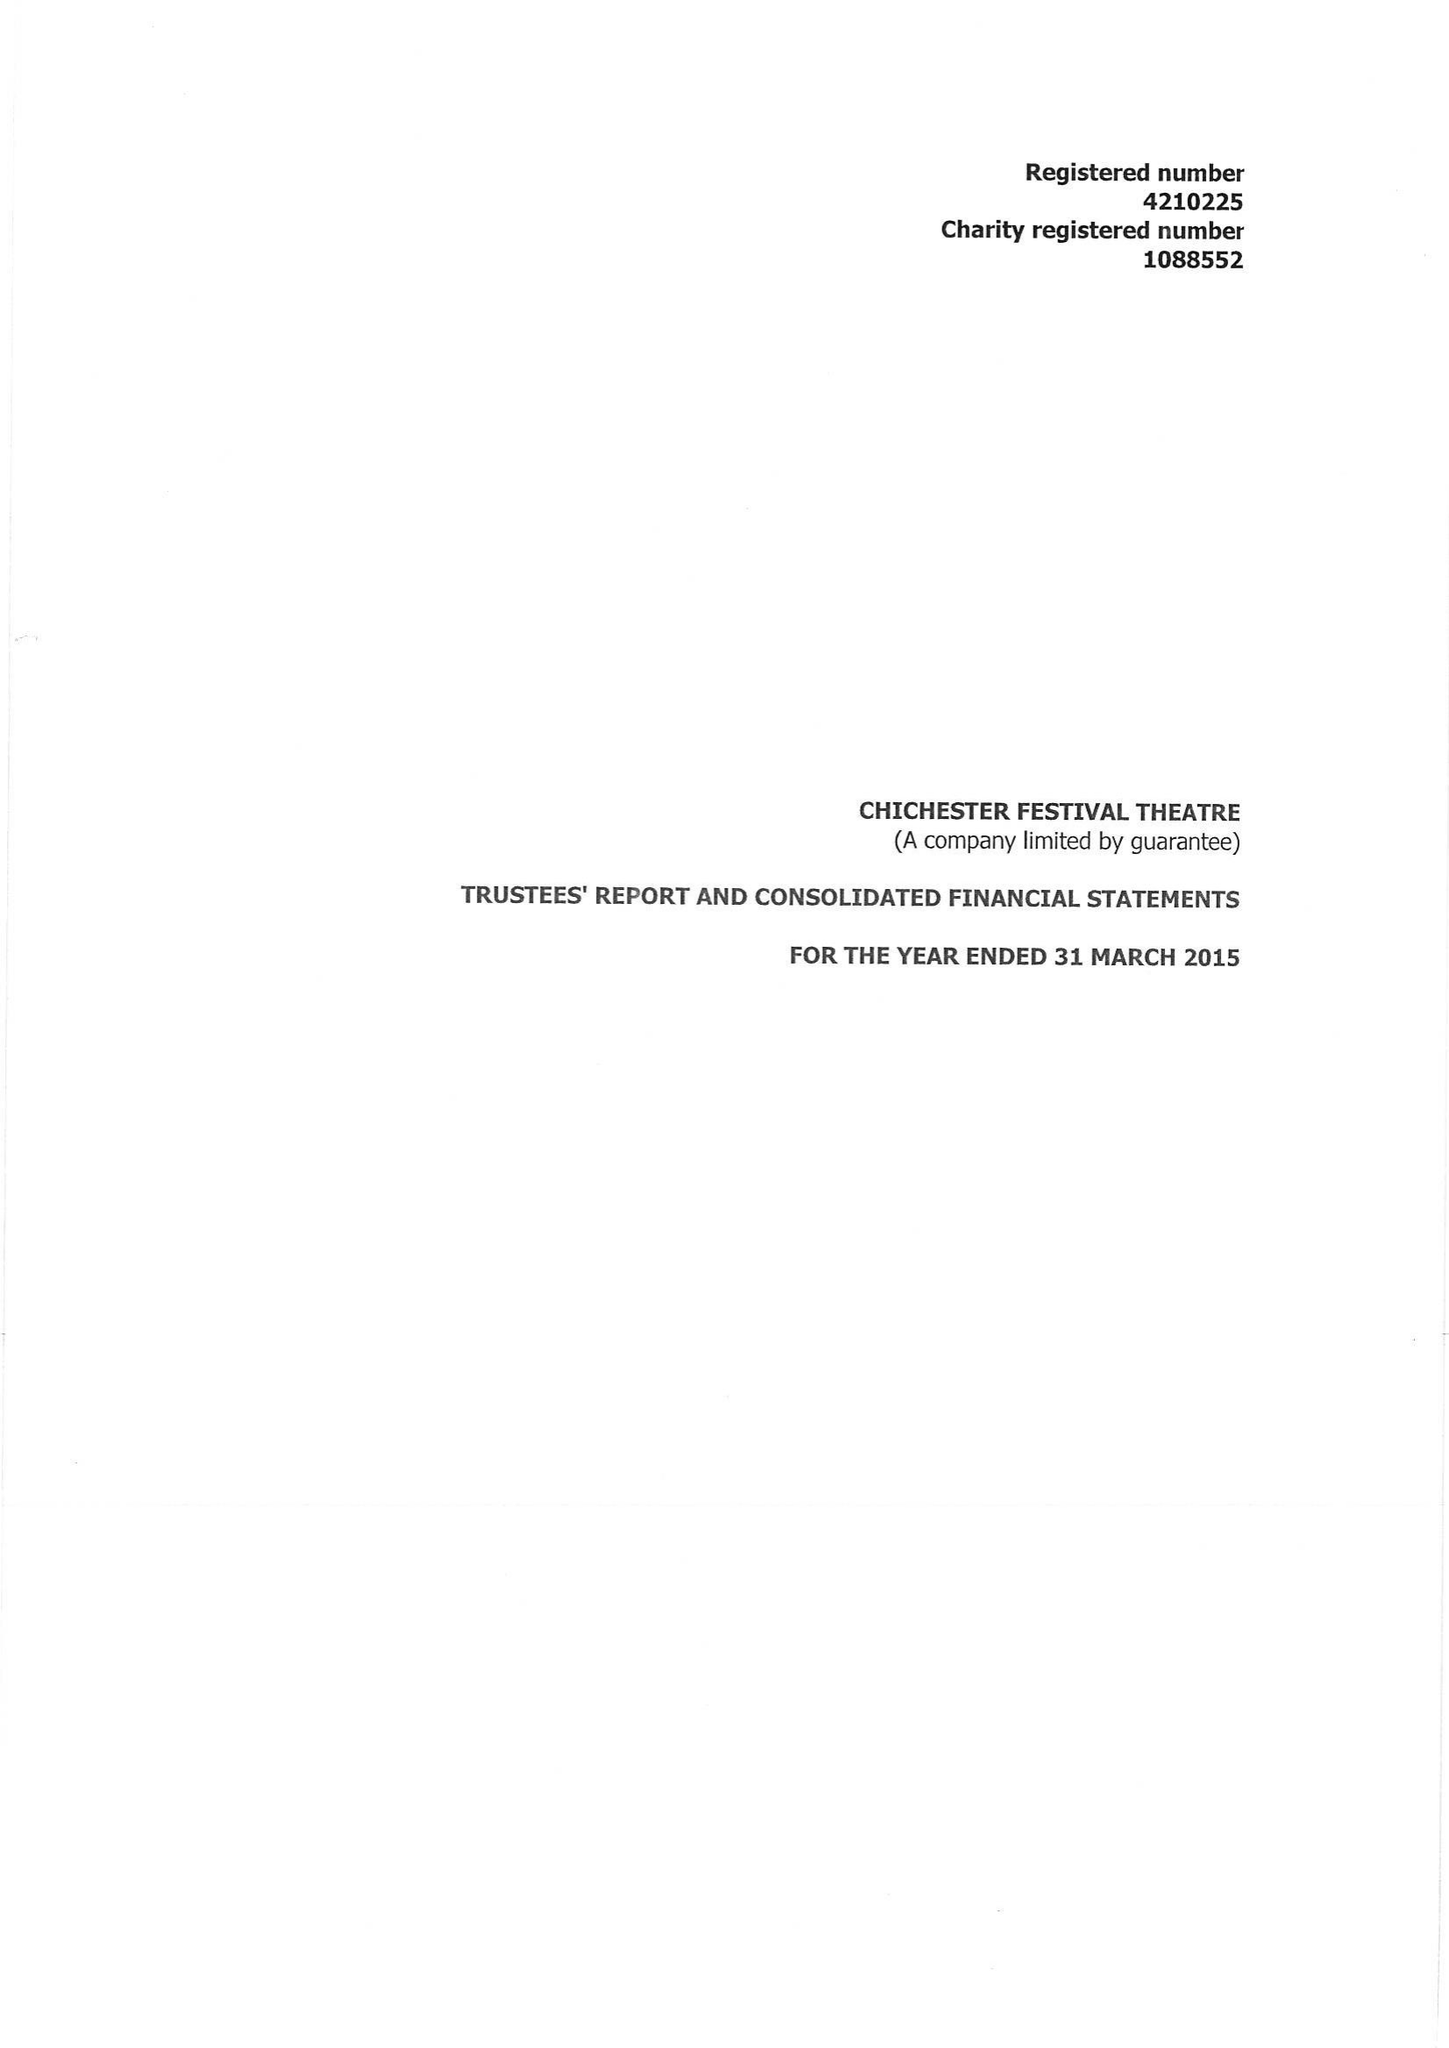What is the value for the address__postcode?
Answer the question using a single word or phrase. PO19 6AP 